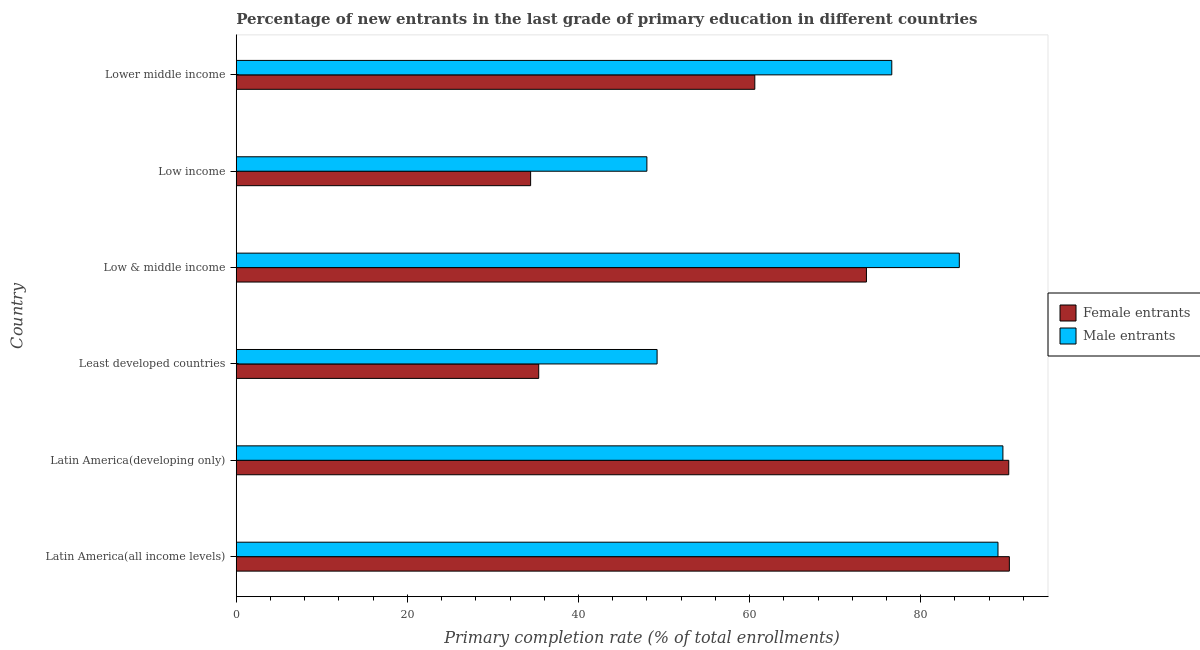How many different coloured bars are there?
Give a very brief answer. 2. Are the number of bars per tick equal to the number of legend labels?
Make the answer very short. Yes. How many bars are there on the 2nd tick from the top?
Your response must be concise. 2. What is the label of the 4th group of bars from the top?
Provide a short and direct response. Least developed countries. In how many cases, is the number of bars for a given country not equal to the number of legend labels?
Your response must be concise. 0. What is the primary completion rate of male entrants in Low & middle income?
Provide a succinct answer. 84.52. Across all countries, what is the maximum primary completion rate of male entrants?
Your answer should be very brief. 89.61. Across all countries, what is the minimum primary completion rate of female entrants?
Your response must be concise. 34.41. In which country was the primary completion rate of male entrants maximum?
Keep it short and to the point. Latin America(developing only). What is the total primary completion rate of female entrants in the graph?
Your answer should be compact. 384.7. What is the difference between the primary completion rate of female entrants in Latin America(developing only) and that in Low income?
Keep it short and to the point. 55.89. What is the difference between the primary completion rate of male entrants in Latin America(developing only) and the primary completion rate of female entrants in Low income?
Your answer should be compact. 55.2. What is the average primary completion rate of female entrants per country?
Give a very brief answer. 64.12. What is the difference between the primary completion rate of male entrants and primary completion rate of female entrants in Low & middle income?
Give a very brief answer. 10.86. In how many countries, is the primary completion rate of female entrants greater than 68 %?
Provide a short and direct response. 3. What is the ratio of the primary completion rate of female entrants in Latin America(all income levels) to that in Low income?
Your response must be concise. 2.63. Is the primary completion rate of male entrants in Least developed countries less than that in Lower middle income?
Your answer should be compact. Yes. What is the difference between the highest and the second highest primary completion rate of female entrants?
Keep it short and to the point. 0.07. What is the difference between the highest and the lowest primary completion rate of male entrants?
Make the answer very short. 41.61. In how many countries, is the primary completion rate of male entrants greater than the average primary completion rate of male entrants taken over all countries?
Your answer should be very brief. 4. Is the sum of the primary completion rate of female entrants in Latin America(developing only) and Least developed countries greater than the maximum primary completion rate of male entrants across all countries?
Provide a short and direct response. Yes. What does the 1st bar from the top in Latin America(developing only) represents?
Ensure brevity in your answer.  Male entrants. What does the 1st bar from the bottom in Least developed countries represents?
Your answer should be compact. Female entrants. What is the difference between two consecutive major ticks on the X-axis?
Your answer should be very brief. 20. Are the values on the major ticks of X-axis written in scientific E-notation?
Provide a short and direct response. No. Where does the legend appear in the graph?
Provide a short and direct response. Center right. What is the title of the graph?
Provide a short and direct response. Percentage of new entrants in the last grade of primary education in different countries. Does "Investment" appear as one of the legend labels in the graph?
Your answer should be very brief. No. What is the label or title of the X-axis?
Provide a succinct answer. Primary completion rate (% of total enrollments). What is the label or title of the Y-axis?
Provide a short and direct response. Country. What is the Primary completion rate (% of total enrollments) in Female entrants in Latin America(all income levels)?
Your answer should be very brief. 90.37. What is the Primary completion rate (% of total enrollments) of Male entrants in Latin America(all income levels)?
Give a very brief answer. 89.04. What is the Primary completion rate (% of total enrollments) of Female entrants in Latin America(developing only)?
Make the answer very short. 90.3. What is the Primary completion rate (% of total enrollments) of Male entrants in Latin America(developing only)?
Provide a succinct answer. 89.61. What is the Primary completion rate (% of total enrollments) of Female entrants in Least developed countries?
Provide a short and direct response. 35.35. What is the Primary completion rate (% of total enrollments) of Male entrants in Least developed countries?
Offer a terse response. 49.19. What is the Primary completion rate (% of total enrollments) of Female entrants in Low & middle income?
Offer a terse response. 73.66. What is the Primary completion rate (% of total enrollments) of Male entrants in Low & middle income?
Provide a succinct answer. 84.52. What is the Primary completion rate (% of total enrollments) in Female entrants in Low income?
Your response must be concise. 34.41. What is the Primary completion rate (% of total enrollments) of Male entrants in Low income?
Provide a short and direct response. 48. What is the Primary completion rate (% of total enrollments) in Female entrants in Lower middle income?
Provide a short and direct response. 60.61. What is the Primary completion rate (% of total enrollments) of Male entrants in Lower middle income?
Your answer should be compact. 76.62. Across all countries, what is the maximum Primary completion rate (% of total enrollments) in Female entrants?
Provide a succinct answer. 90.37. Across all countries, what is the maximum Primary completion rate (% of total enrollments) of Male entrants?
Provide a succinct answer. 89.61. Across all countries, what is the minimum Primary completion rate (% of total enrollments) of Female entrants?
Your answer should be compact. 34.41. Across all countries, what is the minimum Primary completion rate (% of total enrollments) of Male entrants?
Give a very brief answer. 48. What is the total Primary completion rate (% of total enrollments) of Female entrants in the graph?
Keep it short and to the point. 384.7. What is the total Primary completion rate (% of total enrollments) in Male entrants in the graph?
Provide a short and direct response. 436.98. What is the difference between the Primary completion rate (% of total enrollments) of Female entrants in Latin America(all income levels) and that in Latin America(developing only)?
Your answer should be compact. 0.07. What is the difference between the Primary completion rate (% of total enrollments) in Male entrants in Latin America(all income levels) and that in Latin America(developing only)?
Your answer should be very brief. -0.57. What is the difference between the Primary completion rate (% of total enrollments) in Female entrants in Latin America(all income levels) and that in Least developed countries?
Make the answer very short. 55.01. What is the difference between the Primary completion rate (% of total enrollments) of Male entrants in Latin America(all income levels) and that in Least developed countries?
Your response must be concise. 39.85. What is the difference between the Primary completion rate (% of total enrollments) of Female entrants in Latin America(all income levels) and that in Low & middle income?
Your response must be concise. 16.7. What is the difference between the Primary completion rate (% of total enrollments) in Male entrants in Latin America(all income levels) and that in Low & middle income?
Ensure brevity in your answer.  4.52. What is the difference between the Primary completion rate (% of total enrollments) in Female entrants in Latin America(all income levels) and that in Low income?
Your response must be concise. 55.96. What is the difference between the Primary completion rate (% of total enrollments) in Male entrants in Latin America(all income levels) and that in Low income?
Provide a short and direct response. 41.04. What is the difference between the Primary completion rate (% of total enrollments) in Female entrants in Latin America(all income levels) and that in Lower middle income?
Provide a succinct answer. 29.75. What is the difference between the Primary completion rate (% of total enrollments) in Male entrants in Latin America(all income levels) and that in Lower middle income?
Your answer should be very brief. 12.41. What is the difference between the Primary completion rate (% of total enrollments) in Female entrants in Latin America(developing only) and that in Least developed countries?
Make the answer very short. 54.94. What is the difference between the Primary completion rate (% of total enrollments) in Male entrants in Latin America(developing only) and that in Least developed countries?
Your answer should be compact. 40.42. What is the difference between the Primary completion rate (% of total enrollments) in Female entrants in Latin America(developing only) and that in Low & middle income?
Offer a terse response. 16.63. What is the difference between the Primary completion rate (% of total enrollments) of Male entrants in Latin America(developing only) and that in Low & middle income?
Provide a succinct answer. 5.09. What is the difference between the Primary completion rate (% of total enrollments) of Female entrants in Latin America(developing only) and that in Low income?
Ensure brevity in your answer.  55.89. What is the difference between the Primary completion rate (% of total enrollments) in Male entrants in Latin America(developing only) and that in Low income?
Ensure brevity in your answer.  41.61. What is the difference between the Primary completion rate (% of total enrollments) in Female entrants in Latin America(developing only) and that in Lower middle income?
Keep it short and to the point. 29.68. What is the difference between the Primary completion rate (% of total enrollments) of Male entrants in Latin America(developing only) and that in Lower middle income?
Ensure brevity in your answer.  12.99. What is the difference between the Primary completion rate (% of total enrollments) of Female entrants in Least developed countries and that in Low & middle income?
Make the answer very short. -38.31. What is the difference between the Primary completion rate (% of total enrollments) in Male entrants in Least developed countries and that in Low & middle income?
Give a very brief answer. -35.33. What is the difference between the Primary completion rate (% of total enrollments) in Female entrants in Least developed countries and that in Low income?
Offer a very short reply. 0.95. What is the difference between the Primary completion rate (% of total enrollments) in Male entrants in Least developed countries and that in Low income?
Your response must be concise. 1.19. What is the difference between the Primary completion rate (% of total enrollments) in Female entrants in Least developed countries and that in Lower middle income?
Ensure brevity in your answer.  -25.26. What is the difference between the Primary completion rate (% of total enrollments) of Male entrants in Least developed countries and that in Lower middle income?
Keep it short and to the point. -27.43. What is the difference between the Primary completion rate (% of total enrollments) in Female entrants in Low & middle income and that in Low income?
Your answer should be compact. 39.25. What is the difference between the Primary completion rate (% of total enrollments) in Male entrants in Low & middle income and that in Low income?
Keep it short and to the point. 36.52. What is the difference between the Primary completion rate (% of total enrollments) of Female entrants in Low & middle income and that in Lower middle income?
Make the answer very short. 13.05. What is the difference between the Primary completion rate (% of total enrollments) of Male entrants in Low & middle income and that in Lower middle income?
Provide a short and direct response. 7.89. What is the difference between the Primary completion rate (% of total enrollments) of Female entrants in Low income and that in Lower middle income?
Make the answer very short. -26.21. What is the difference between the Primary completion rate (% of total enrollments) in Male entrants in Low income and that in Lower middle income?
Offer a very short reply. -28.63. What is the difference between the Primary completion rate (% of total enrollments) of Female entrants in Latin America(all income levels) and the Primary completion rate (% of total enrollments) of Male entrants in Latin America(developing only)?
Give a very brief answer. 0.75. What is the difference between the Primary completion rate (% of total enrollments) in Female entrants in Latin America(all income levels) and the Primary completion rate (% of total enrollments) in Male entrants in Least developed countries?
Give a very brief answer. 41.17. What is the difference between the Primary completion rate (% of total enrollments) of Female entrants in Latin America(all income levels) and the Primary completion rate (% of total enrollments) of Male entrants in Low & middle income?
Your response must be concise. 5.85. What is the difference between the Primary completion rate (% of total enrollments) of Female entrants in Latin America(all income levels) and the Primary completion rate (% of total enrollments) of Male entrants in Low income?
Provide a short and direct response. 42.37. What is the difference between the Primary completion rate (% of total enrollments) of Female entrants in Latin America(all income levels) and the Primary completion rate (% of total enrollments) of Male entrants in Lower middle income?
Your answer should be compact. 13.74. What is the difference between the Primary completion rate (% of total enrollments) of Female entrants in Latin America(developing only) and the Primary completion rate (% of total enrollments) of Male entrants in Least developed countries?
Keep it short and to the point. 41.1. What is the difference between the Primary completion rate (% of total enrollments) in Female entrants in Latin America(developing only) and the Primary completion rate (% of total enrollments) in Male entrants in Low & middle income?
Your response must be concise. 5.78. What is the difference between the Primary completion rate (% of total enrollments) in Female entrants in Latin America(developing only) and the Primary completion rate (% of total enrollments) in Male entrants in Low income?
Make the answer very short. 42.3. What is the difference between the Primary completion rate (% of total enrollments) in Female entrants in Latin America(developing only) and the Primary completion rate (% of total enrollments) in Male entrants in Lower middle income?
Offer a very short reply. 13.67. What is the difference between the Primary completion rate (% of total enrollments) of Female entrants in Least developed countries and the Primary completion rate (% of total enrollments) of Male entrants in Low & middle income?
Provide a succinct answer. -49.16. What is the difference between the Primary completion rate (% of total enrollments) of Female entrants in Least developed countries and the Primary completion rate (% of total enrollments) of Male entrants in Low income?
Make the answer very short. -12.64. What is the difference between the Primary completion rate (% of total enrollments) in Female entrants in Least developed countries and the Primary completion rate (% of total enrollments) in Male entrants in Lower middle income?
Your answer should be compact. -41.27. What is the difference between the Primary completion rate (% of total enrollments) of Female entrants in Low & middle income and the Primary completion rate (% of total enrollments) of Male entrants in Low income?
Give a very brief answer. 25.66. What is the difference between the Primary completion rate (% of total enrollments) in Female entrants in Low & middle income and the Primary completion rate (% of total enrollments) in Male entrants in Lower middle income?
Keep it short and to the point. -2.96. What is the difference between the Primary completion rate (% of total enrollments) of Female entrants in Low income and the Primary completion rate (% of total enrollments) of Male entrants in Lower middle income?
Your answer should be compact. -42.22. What is the average Primary completion rate (% of total enrollments) in Female entrants per country?
Keep it short and to the point. 64.12. What is the average Primary completion rate (% of total enrollments) in Male entrants per country?
Make the answer very short. 72.83. What is the difference between the Primary completion rate (% of total enrollments) in Female entrants and Primary completion rate (% of total enrollments) in Male entrants in Latin America(all income levels)?
Offer a terse response. 1.33. What is the difference between the Primary completion rate (% of total enrollments) of Female entrants and Primary completion rate (% of total enrollments) of Male entrants in Latin America(developing only)?
Provide a succinct answer. 0.68. What is the difference between the Primary completion rate (% of total enrollments) of Female entrants and Primary completion rate (% of total enrollments) of Male entrants in Least developed countries?
Your answer should be compact. -13.84. What is the difference between the Primary completion rate (% of total enrollments) in Female entrants and Primary completion rate (% of total enrollments) in Male entrants in Low & middle income?
Provide a succinct answer. -10.86. What is the difference between the Primary completion rate (% of total enrollments) of Female entrants and Primary completion rate (% of total enrollments) of Male entrants in Low income?
Provide a succinct answer. -13.59. What is the difference between the Primary completion rate (% of total enrollments) in Female entrants and Primary completion rate (% of total enrollments) in Male entrants in Lower middle income?
Offer a very short reply. -16.01. What is the ratio of the Primary completion rate (% of total enrollments) in Female entrants in Latin America(all income levels) to that in Latin America(developing only)?
Offer a very short reply. 1. What is the ratio of the Primary completion rate (% of total enrollments) of Female entrants in Latin America(all income levels) to that in Least developed countries?
Give a very brief answer. 2.56. What is the ratio of the Primary completion rate (% of total enrollments) of Male entrants in Latin America(all income levels) to that in Least developed countries?
Provide a short and direct response. 1.81. What is the ratio of the Primary completion rate (% of total enrollments) in Female entrants in Latin America(all income levels) to that in Low & middle income?
Provide a short and direct response. 1.23. What is the ratio of the Primary completion rate (% of total enrollments) in Male entrants in Latin America(all income levels) to that in Low & middle income?
Provide a short and direct response. 1.05. What is the ratio of the Primary completion rate (% of total enrollments) of Female entrants in Latin America(all income levels) to that in Low income?
Give a very brief answer. 2.63. What is the ratio of the Primary completion rate (% of total enrollments) in Male entrants in Latin America(all income levels) to that in Low income?
Your answer should be very brief. 1.85. What is the ratio of the Primary completion rate (% of total enrollments) of Female entrants in Latin America(all income levels) to that in Lower middle income?
Offer a terse response. 1.49. What is the ratio of the Primary completion rate (% of total enrollments) in Male entrants in Latin America(all income levels) to that in Lower middle income?
Your answer should be very brief. 1.16. What is the ratio of the Primary completion rate (% of total enrollments) of Female entrants in Latin America(developing only) to that in Least developed countries?
Offer a terse response. 2.55. What is the ratio of the Primary completion rate (% of total enrollments) of Male entrants in Latin America(developing only) to that in Least developed countries?
Offer a terse response. 1.82. What is the ratio of the Primary completion rate (% of total enrollments) of Female entrants in Latin America(developing only) to that in Low & middle income?
Provide a short and direct response. 1.23. What is the ratio of the Primary completion rate (% of total enrollments) of Male entrants in Latin America(developing only) to that in Low & middle income?
Offer a very short reply. 1.06. What is the ratio of the Primary completion rate (% of total enrollments) of Female entrants in Latin America(developing only) to that in Low income?
Provide a short and direct response. 2.62. What is the ratio of the Primary completion rate (% of total enrollments) of Male entrants in Latin America(developing only) to that in Low income?
Keep it short and to the point. 1.87. What is the ratio of the Primary completion rate (% of total enrollments) in Female entrants in Latin America(developing only) to that in Lower middle income?
Give a very brief answer. 1.49. What is the ratio of the Primary completion rate (% of total enrollments) in Male entrants in Latin America(developing only) to that in Lower middle income?
Your answer should be compact. 1.17. What is the ratio of the Primary completion rate (% of total enrollments) of Female entrants in Least developed countries to that in Low & middle income?
Your answer should be very brief. 0.48. What is the ratio of the Primary completion rate (% of total enrollments) of Male entrants in Least developed countries to that in Low & middle income?
Ensure brevity in your answer.  0.58. What is the ratio of the Primary completion rate (% of total enrollments) of Female entrants in Least developed countries to that in Low income?
Keep it short and to the point. 1.03. What is the ratio of the Primary completion rate (% of total enrollments) of Male entrants in Least developed countries to that in Low income?
Offer a terse response. 1.02. What is the ratio of the Primary completion rate (% of total enrollments) of Female entrants in Least developed countries to that in Lower middle income?
Give a very brief answer. 0.58. What is the ratio of the Primary completion rate (% of total enrollments) in Male entrants in Least developed countries to that in Lower middle income?
Provide a succinct answer. 0.64. What is the ratio of the Primary completion rate (% of total enrollments) of Female entrants in Low & middle income to that in Low income?
Offer a terse response. 2.14. What is the ratio of the Primary completion rate (% of total enrollments) of Male entrants in Low & middle income to that in Low income?
Give a very brief answer. 1.76. What is the ratio of the Primary completion rate (% of total enrollments) in Female entrants in Low & middle income to that in Lower middle income?
Ensure brevity in your answer.  1.22. What is the ratio of the Primary completion rate (% of total enrollments) of Male entrants in Low & middle income to that in Lower middle income?
Offer a very short reply. 1.1. What is the ratio of the Primary completion rate (% of total enrollments) in Female entrants in Low income to that in Lower middle income?
Your answer should be very brief. 0.57. What is the ratio of the Primary completion rate (% of total enrollments) in Male entrants in Low income to that in Lower middle income?
Keep it short and to the point. 0.63. What is the difference between the highest and the second highest Primary completion rate (% of total enrollments) of Female entrants?
Provide a short and direct response. 0.07. What is the difference between the highest and the second highest Primary completion rate (% of total enrollments) of Male entrants?
Offer a terse response. 0.57. What is the difference between the highest and the lowest Primary completion rate (% of total enrollments) in Female entrants?
Make the answer very short. 55.96. What is the difference between the highest and the lowest Primary completion rate (% of total enrollments) of Male entrants?
Give a very brief answer. 41.61. 